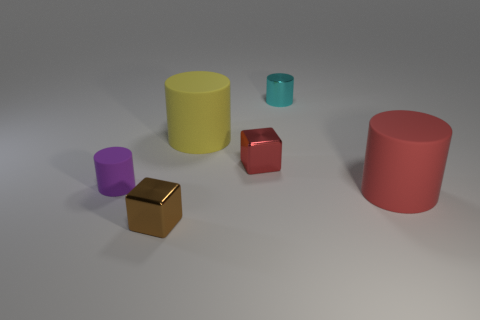Subtract all cyan cylinders. How many cylinders are left? 3 Subtract all cyan shiny cylinders. How many cylinders are left? 3 Subtract all gray blocks. How many red cylinders are left? 1 Add 3 small blue rubber cylinders. How many objects exist? 9 Subtract 1 cyan cylinders. How many objects are left? 5 Subtract all blocks. How many objects are left? 4 Subtract 2 cylinders. How many cylinders are left? 2 Subtract all cyan cubes. Subtract all purple balls. How many cubes are left? 2 Subtract all red objects. Subtract all large cyan shiny things. How many objects are left? 4 Add 2 red matte things. How many red matte things are left? 3 